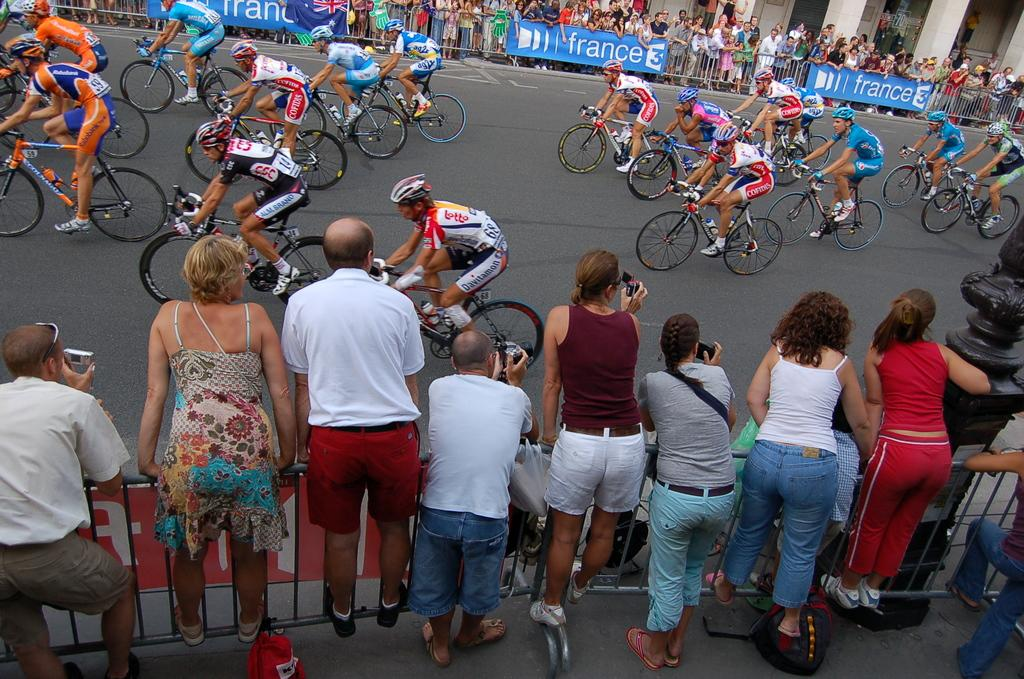What activity are the people in the image engaged in? The people in the image are riding bicycles. What can be seen on both sides of the road in the image? There are crowds on the left and right sides of the road in the image. How many kittens are present in the image? There are no kittens present in the image. Can you compare the size of the crowds on the left and right sides of the road in the image? The provided facts do not include information about the size of the crowds, so it is not possible to make a comparison. 